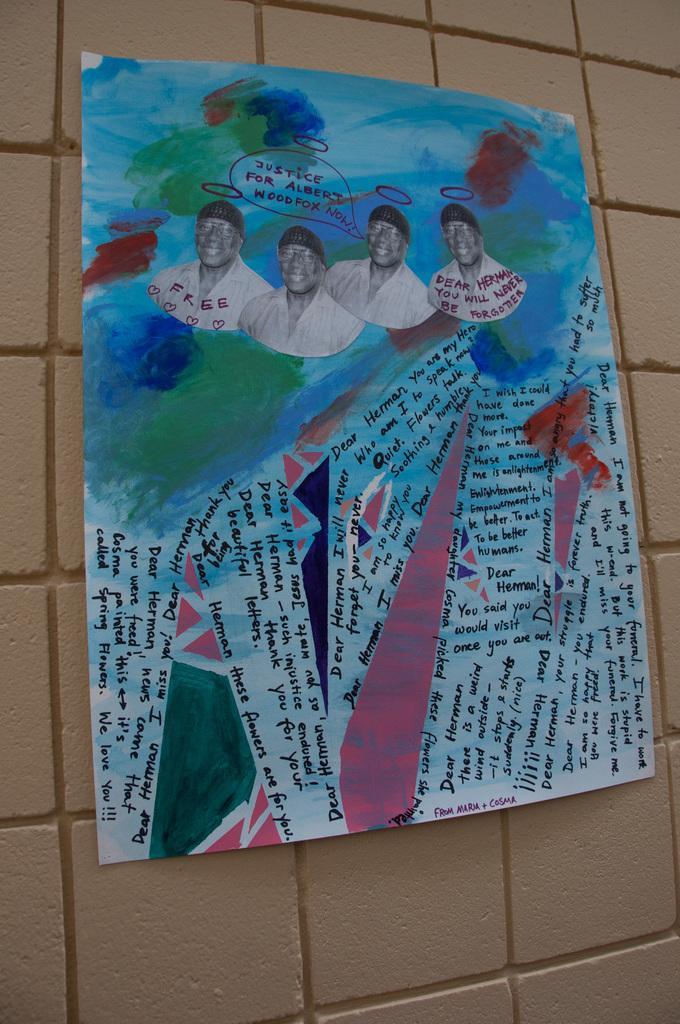Can you describe this image briefly? We can see poster on a wall,on this poster we can see people. 